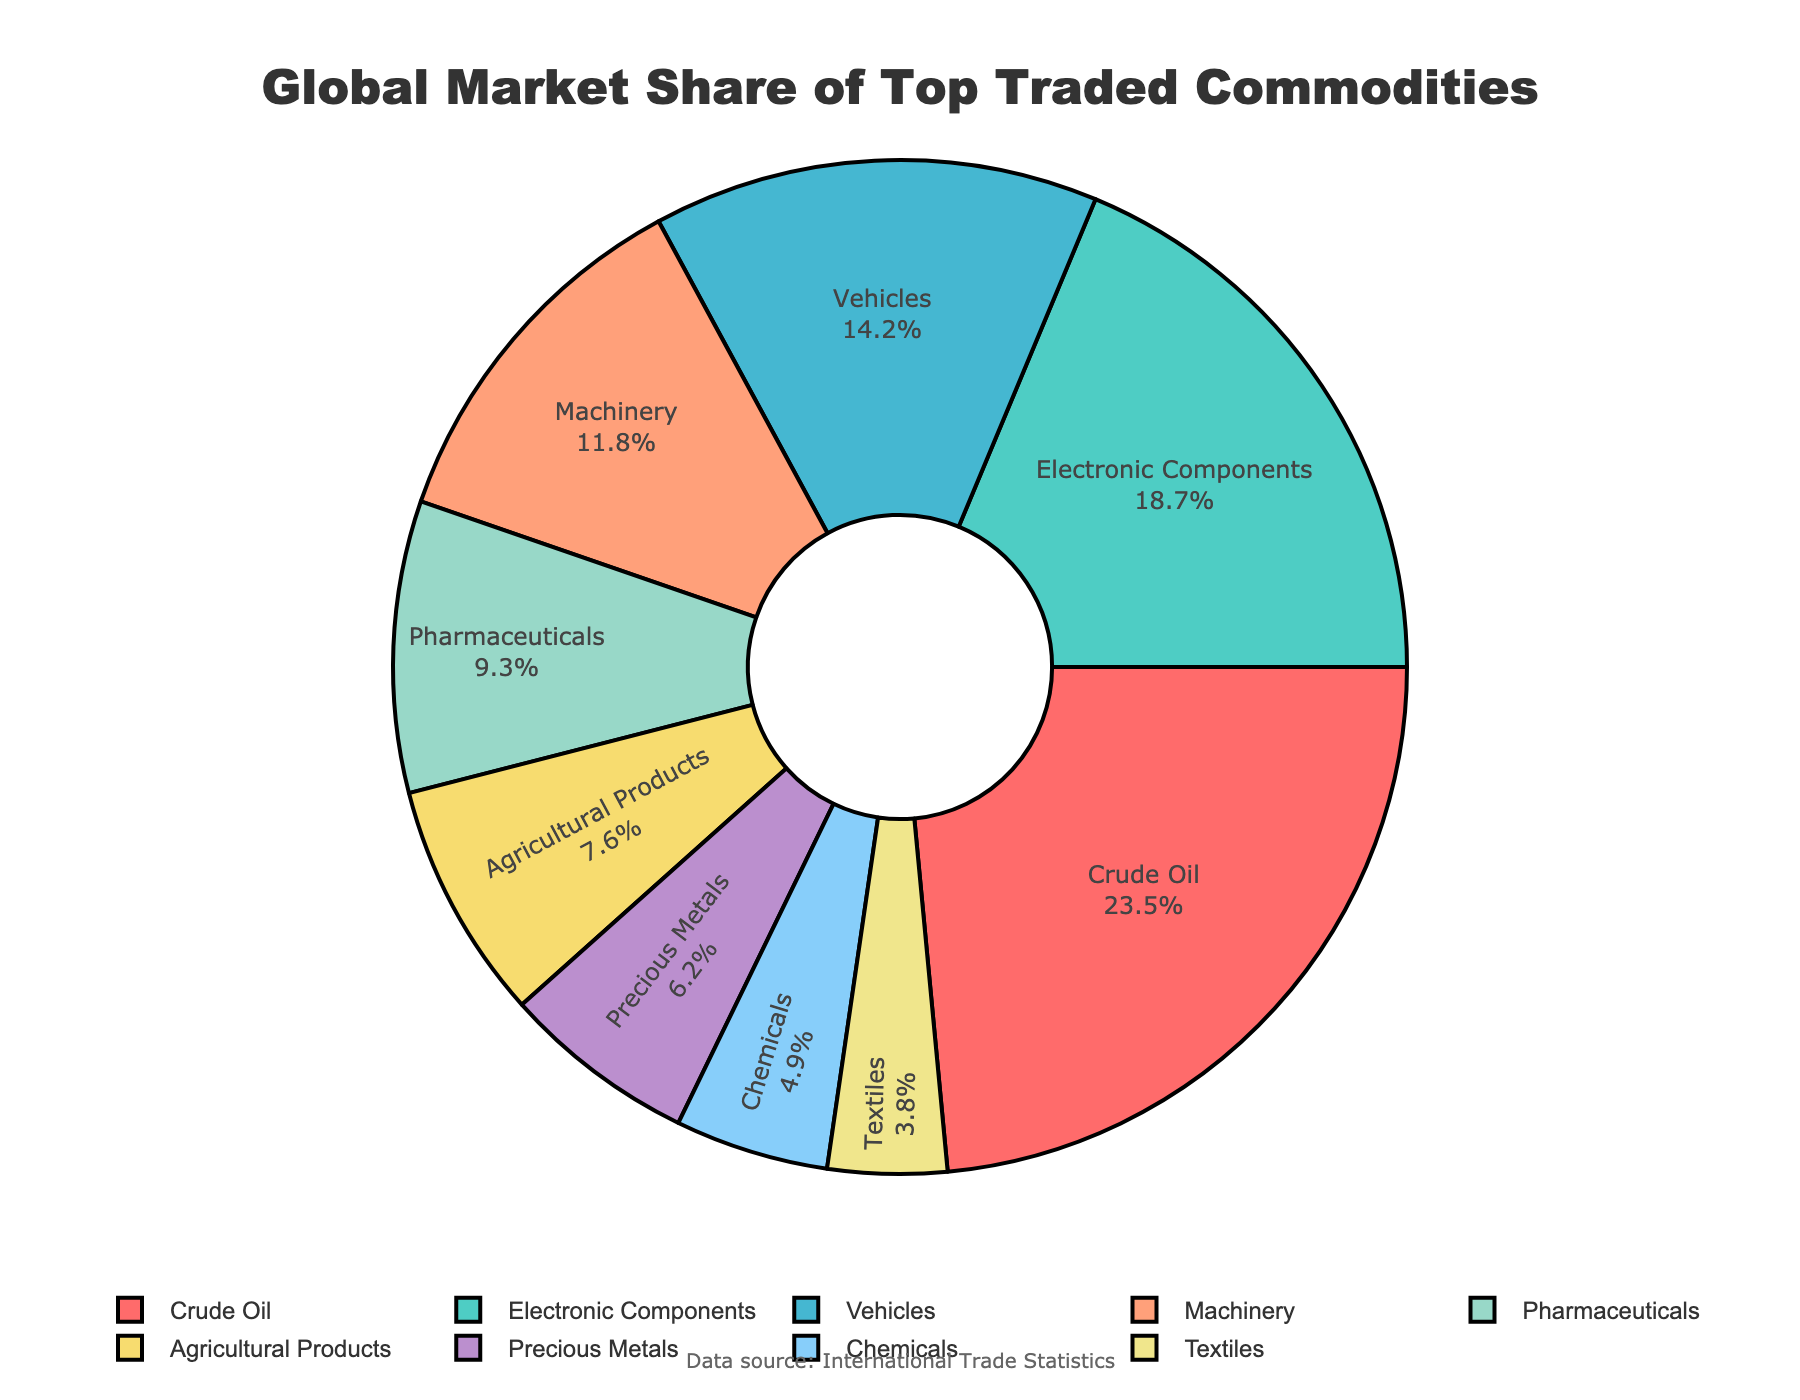What is the market share of Crude Oil? To find the market share of Crude Oil, look at the section of the pie chart labeled "Crude Oil" and check the associated percentage.
Answer: 23.5% Which commodity has the lowest market share? To determine the commodity with the lowest market share, identify the smallest section of the pie chart and check its label.
Answer: Textiles Which two commodities combined have a market share of more than 30%? Add the market shares of different commodities and identify pairs whose sum exceeds 30%. For instance, Crude Oil (23.5%) + Textiles (3.8%) = 27.3%, which is less than 30%. Try different combinations until the condition is met.
Answer: Crude Oil and Electronic Components What is the total market share of the top three commodities? Add the market shares of the top three commodities by looking at the respective sections of the pie chart. Crude Oil (23.5%) + Electronic Components (18.7%) + Vehicles (14.2%) gives 23.5 + 18.7 + 14.2 = 56.4%.
Answer: 56.4% Which commodities have a market share between 10% and 15%? Look at each section of the pie chart and check the labels that indicate market shares between 10% and 15%.
Answer: Vehicles and Machinery How much larger is the market share of Electronic Components compared to Pharmaceuticals? Subtract the market share of Pharmaceuticals from that of Electronic Components: 18.7% - 9.3% = 9.4%.
Answer: 9.4% What is the combined market share of the green and purple sections? Identify the green and purple sections from the pie chart, which correspond to Electronic Components (18.7%) and Precious Metals (6.2%), respectively. Add their market shares: 18.7 + 6.2 = 24.9%.
Answer: 24.9% Which commodity has a higher market share, Agricultural Products or Pharmaceuticals? Compare the sizes of the sections labeled Agricultural Products and Pharmaceuticals in the pie chart. Pharmaceuticals (9.3%) > Agricultural Products (7.6%).
Answer: Pharmaceuticals 